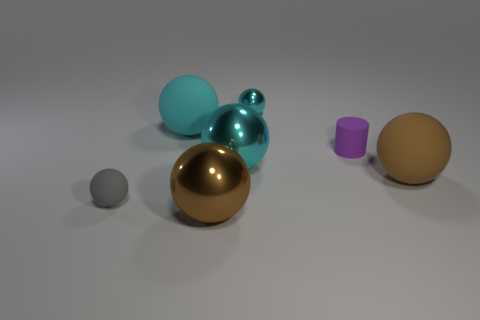The brown shiny object that is the same shape as the gray object is what size?
Your answer should be compact. Large. What number of large objects are cyan metal things or purple rubber objects?
Make the answer very short. 1. Does the object to the right of the cylinder have the same material as the large cyan object that is in front of the cylinder?
Ensure brevity in your answer.  No. There is a small ball that is in front of the big brown matte ball; what is its material?
Keep it short and to the point. Rubber. How many matte things are either small gray objects or cyan cylinders?
Your response must be concise. 1. What is the color of the big rubber sphere right of the big cyan thing in front of the cylinder?
Make the answer very short. Brown. Is the small cyan object made of the same material as the brown thing behind the gray thing?
Give a very brief answer. No. There is a big rubber thing behind the small purple cylinder in front of the ball that is behind the cyan matte thing; what is its color?
Offer a very short reply. Cyan. Are there any other things that are the same shape as the small purple object?
Provide a succinct answer. No. Are there more tiny matte objects than brown rubber spheres?
Provide a short and direct response. Yes. 